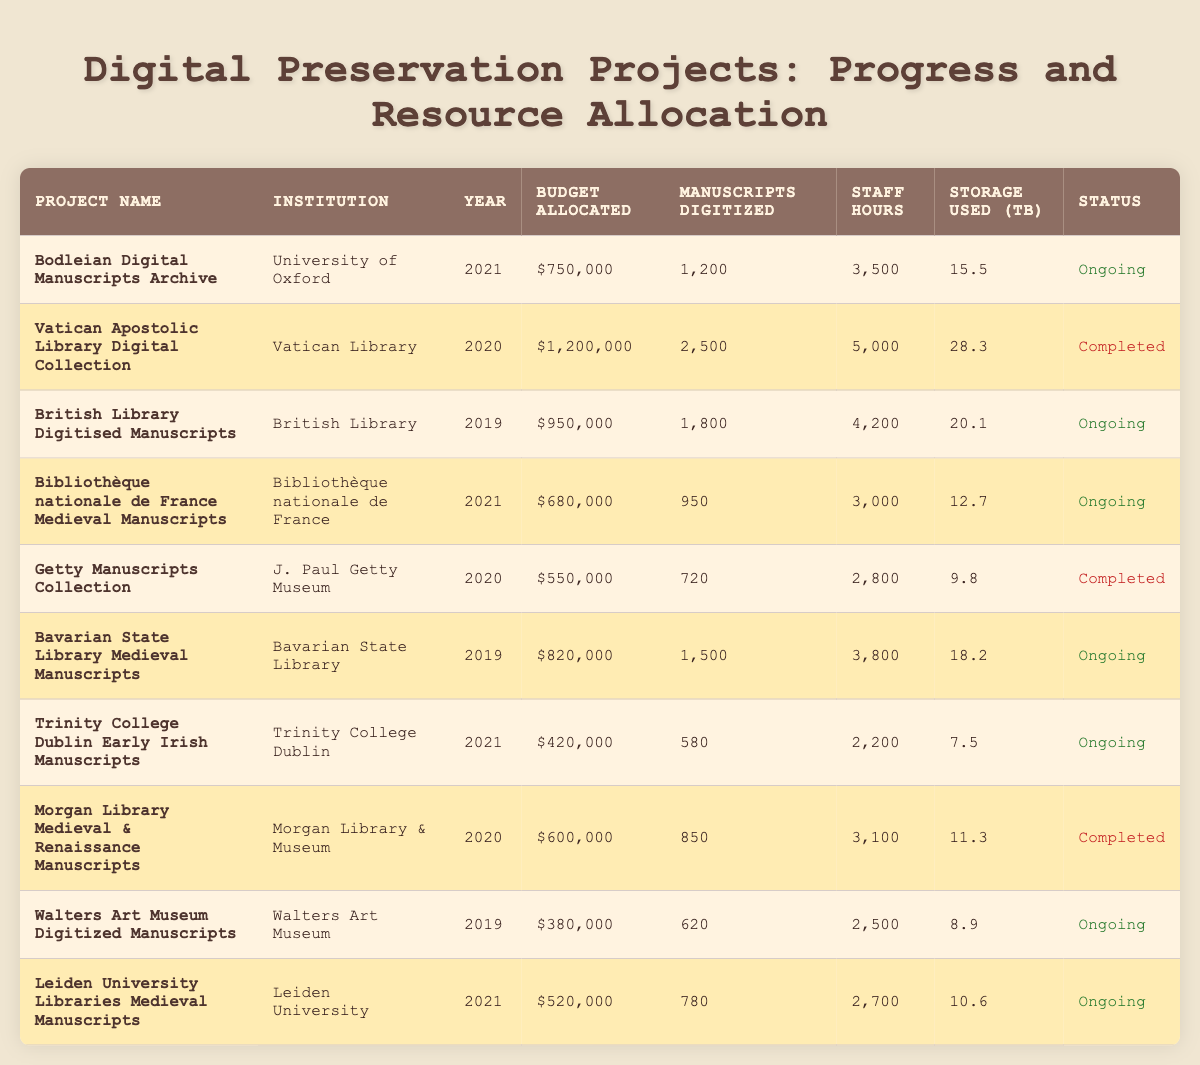What is the budget allocated for the Bodleian Digital Manuscripts Archive? The budget allocated is listed directly in the table for the Bodleian Digital Manuscripts Archive, which shows the value as $750,000.
Answer: $750,000 How many manuscripts were digitized by the Vatican Apostolic Library Digital Collection? The table indicates the number of manuscripts digitized by the Vatican Apostolic Library Digital Collection is 2,500, as cited in the appropriate column.
Answer: 2,500 Which project had the highest budget allocated? To find the project with the highest budget, I reviewed each budget value in the table and found that the Vatican Apostolic Library Digital Collection had the highest budget of $1,200,000.
Answer: $1,200,000 Did the Getty Manuscripts Collection digitize more than 800 manuscripts? Checking the number of manuscripts digitized for the Getty Manuscripts Collection in the table, which states that 720 manuscripts were digitized, confirms that the answer is no.
Answer: No What is the average budget allocated for the ongoing projects? The ongoing projects and their budgets are: Bodleian Digital Manuscripts Archive ($750,000), British Library Digitised Manuscripts ($950,000), Bibliothèque nationale de France Medieval Manuscripts ($680,000), Bavarian State Library Medieval Manuscripts ($820,000), Trinity College Dublin Early Irish Manuscripts ($420,000), Walters Art Museum Digitized Manuscripts ($380,000), and Leiden University Libraries Medieval Manuscripts ($520,000). Summing these budgets gives $750,000 + $950,000 + $680,000 + $820,000 + $420,000 + $380,000 + $520,000 = $3,500,000. There are 7 ongoing projects, hence the average budget allocated is $3,500,000/7 = $500,000.
Answer: $500,000 Which institution's project digitized the fewest manuscripts? I reviewed the number of manuscripts digitized for each project listed in the table. Trinity College Dublin Early Irish Manuscripts digitized 580 manuscripts, which is the least compared to others, confirming it as the project with the fewest manuscripts.
Answer: Trinity College Dublin Early Irish Manuscripts What was the total storage used for completed projects? The completed projects are: Vatican Apostolic Library Digital Collection (28.3 TB), Getty Manuscripts Collection (9.8 TB), and Morgan Library Medieval & Renaissance Manuscripts (11.3 TB). Adding these storage values gives a total of 28.3 TB + 9.8 TB + 11.3 TB = 49.4 TB.
Answer: 49.4 TB Are there more completed projects than ongoing projects? Counting the projects, there are 3 completed projects (Vatican Apostolic Library Digital Collection, Getty Manuscripts Collection, Morgan Library Medieval & Renaissance Manuscripts) and 7 ongoing projects listed. Comparing these counts shows that there are more ongoing projects than completed ones.
Answer: No Which project had the most staff hours recorded, and how many hours were they? Looking through the table, the project with the most staff hours is the Vatican Apostolic Library Digital Collection with 5,000 hours, as revealed in the staff hours column.
Answer: Vatican Apostolic Library Digital Collection, 5,000 hours 